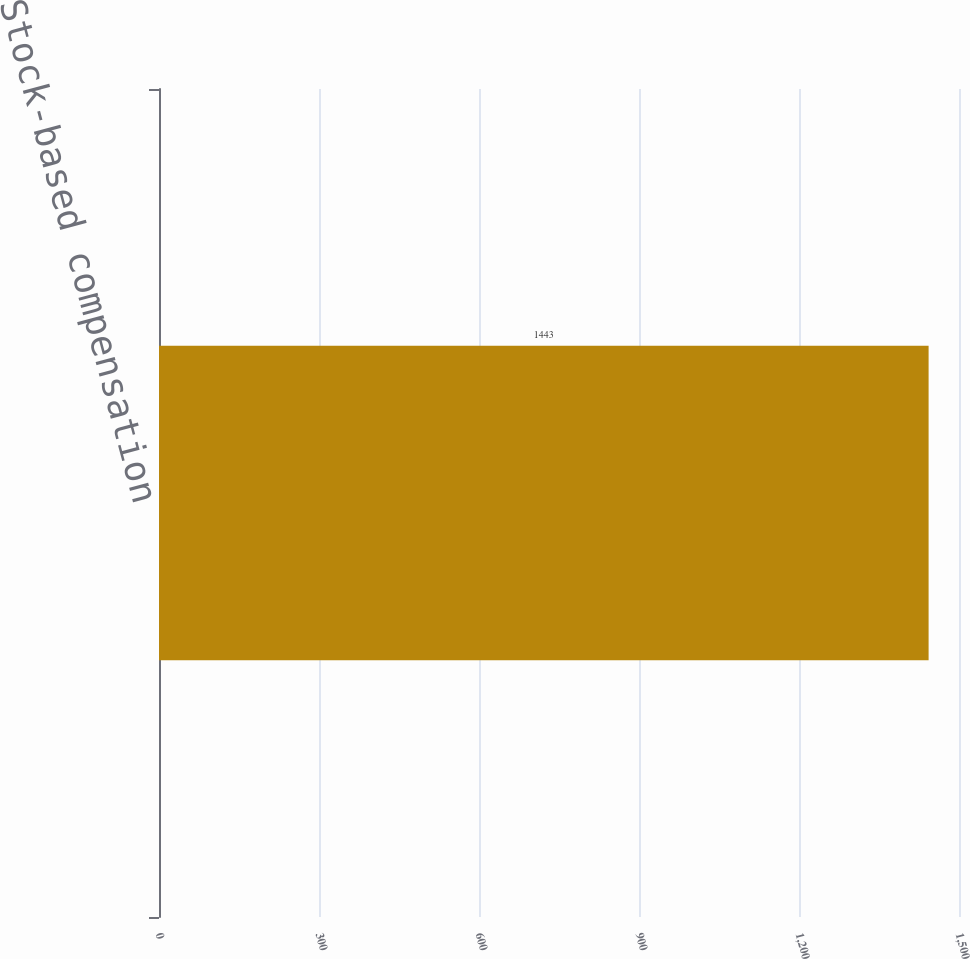Convert chart to OTSL. <chart><loc_0><loc_0><loc_500><loc_500><bar_chart><fcel>Stock-based compensation<nl><fcel>1443<nl></chart> 